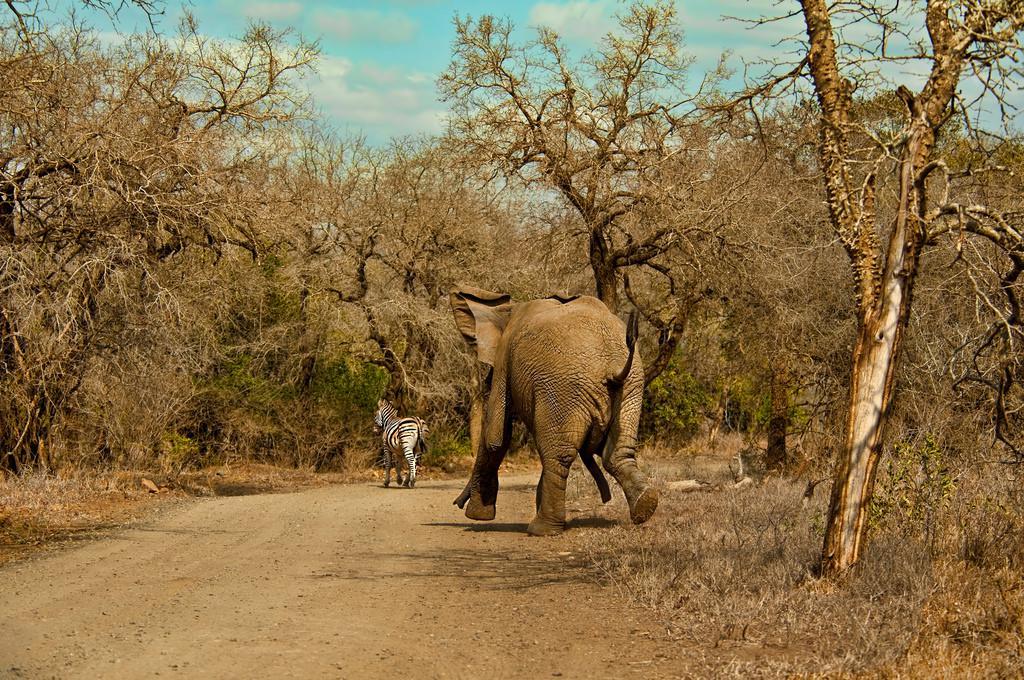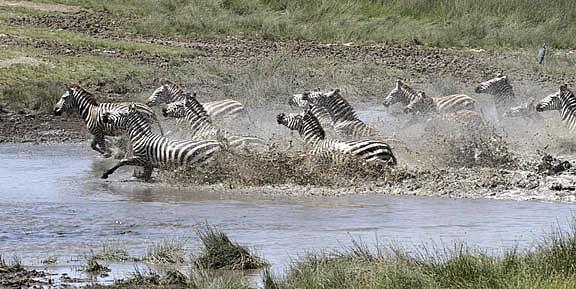The first image is the image on the left, the second image is the image on the right. Considering the images on both sides, is "Zebras are running." valid? Answer yes or no. Yes. The first image is the image on the left, the second image is the image on the right. For the images displayed, is the sentence "The combined images include zebra at a watering hole and a rear-facing elephant near a standing zebra." factually correct? Answer yes or no. Yes. 